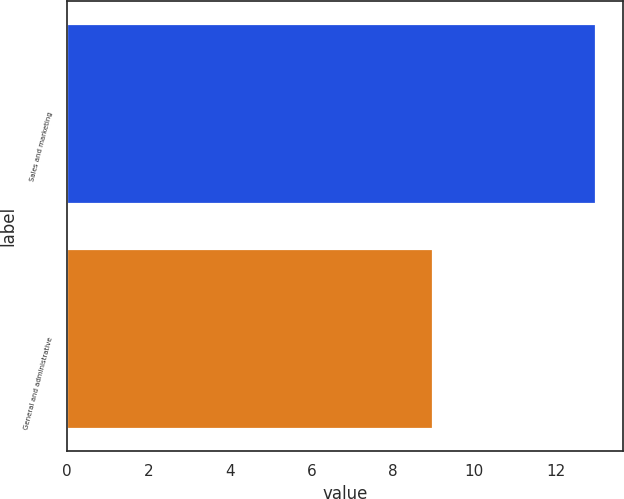<chart> <loc_0><loc_0><loc_500><loc_500><bar_chart><fcel>Sales and marketing<fcel>General and administrative<nl><fcel>13<fcel>9<nl></chart> 